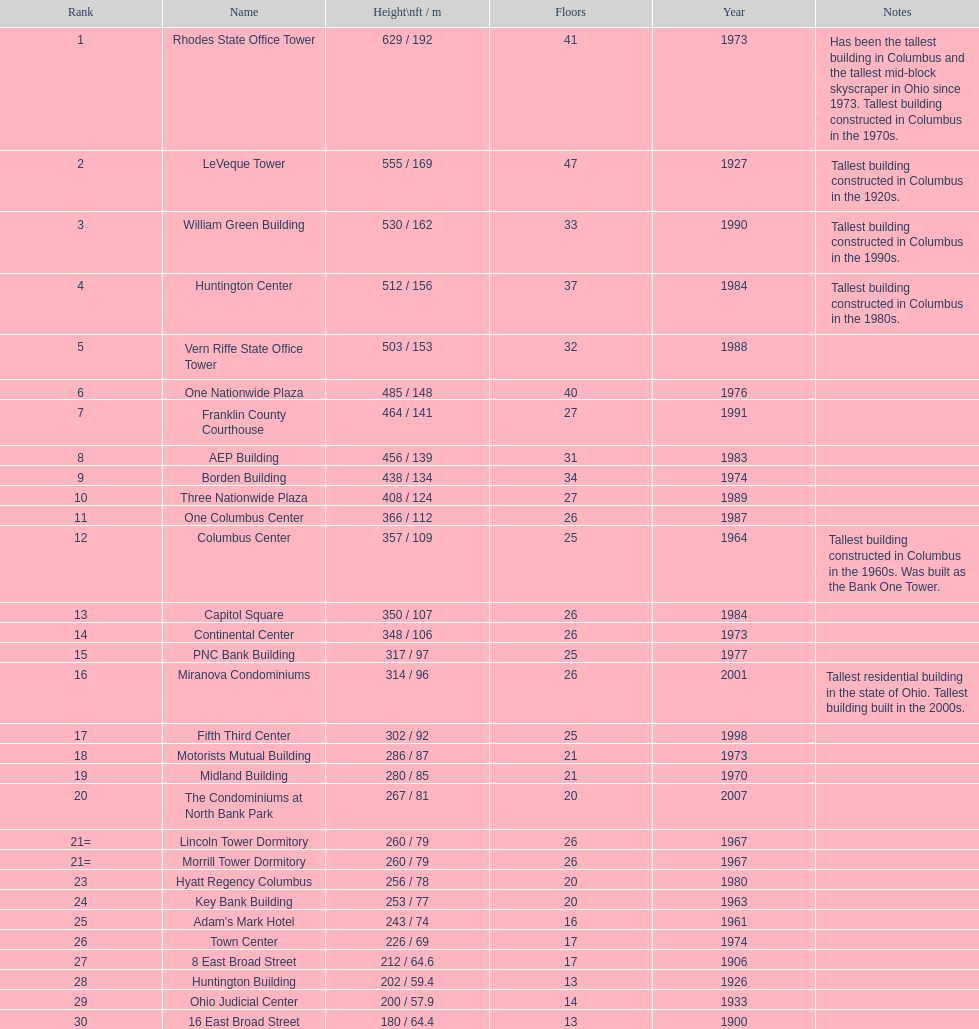Can you tell me the number of floors present in the leveque tower? 47. 